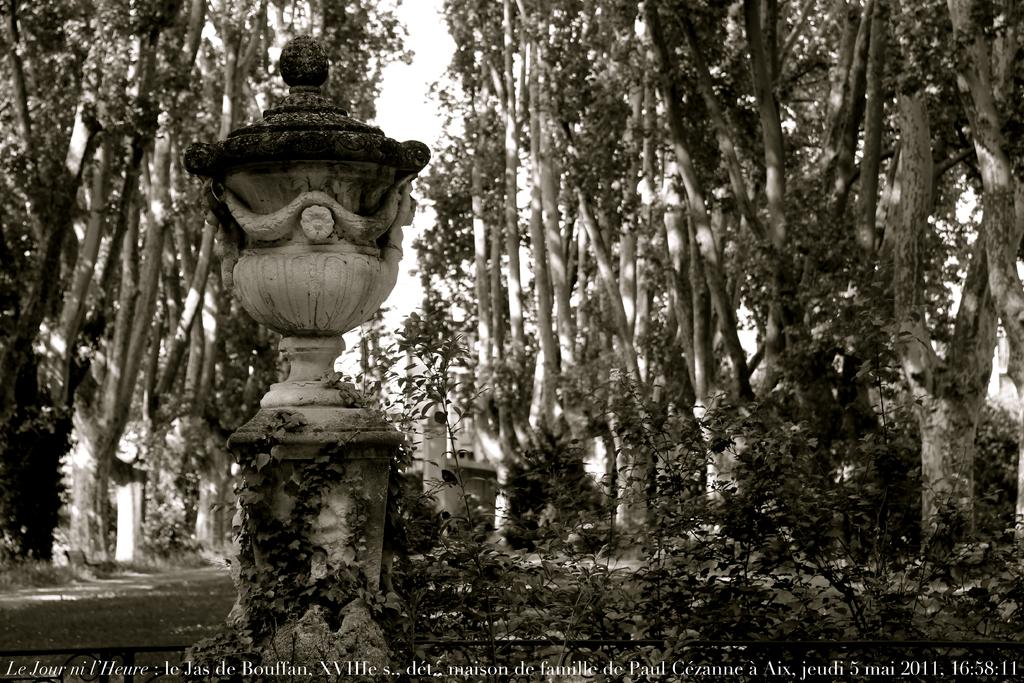What is the main feature in the image? There is a fountain in the image. What can be seen in the background of the image? There are trees and the sky visible in the background of the image. How many apples are hanging from the trees in the image? There are no apples present in the image; only trees can be seen in the background. 